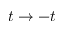Convert formula to latex. <formula><loc_0><loc_0><loc_500><loc_500>t \to - t</formula> 